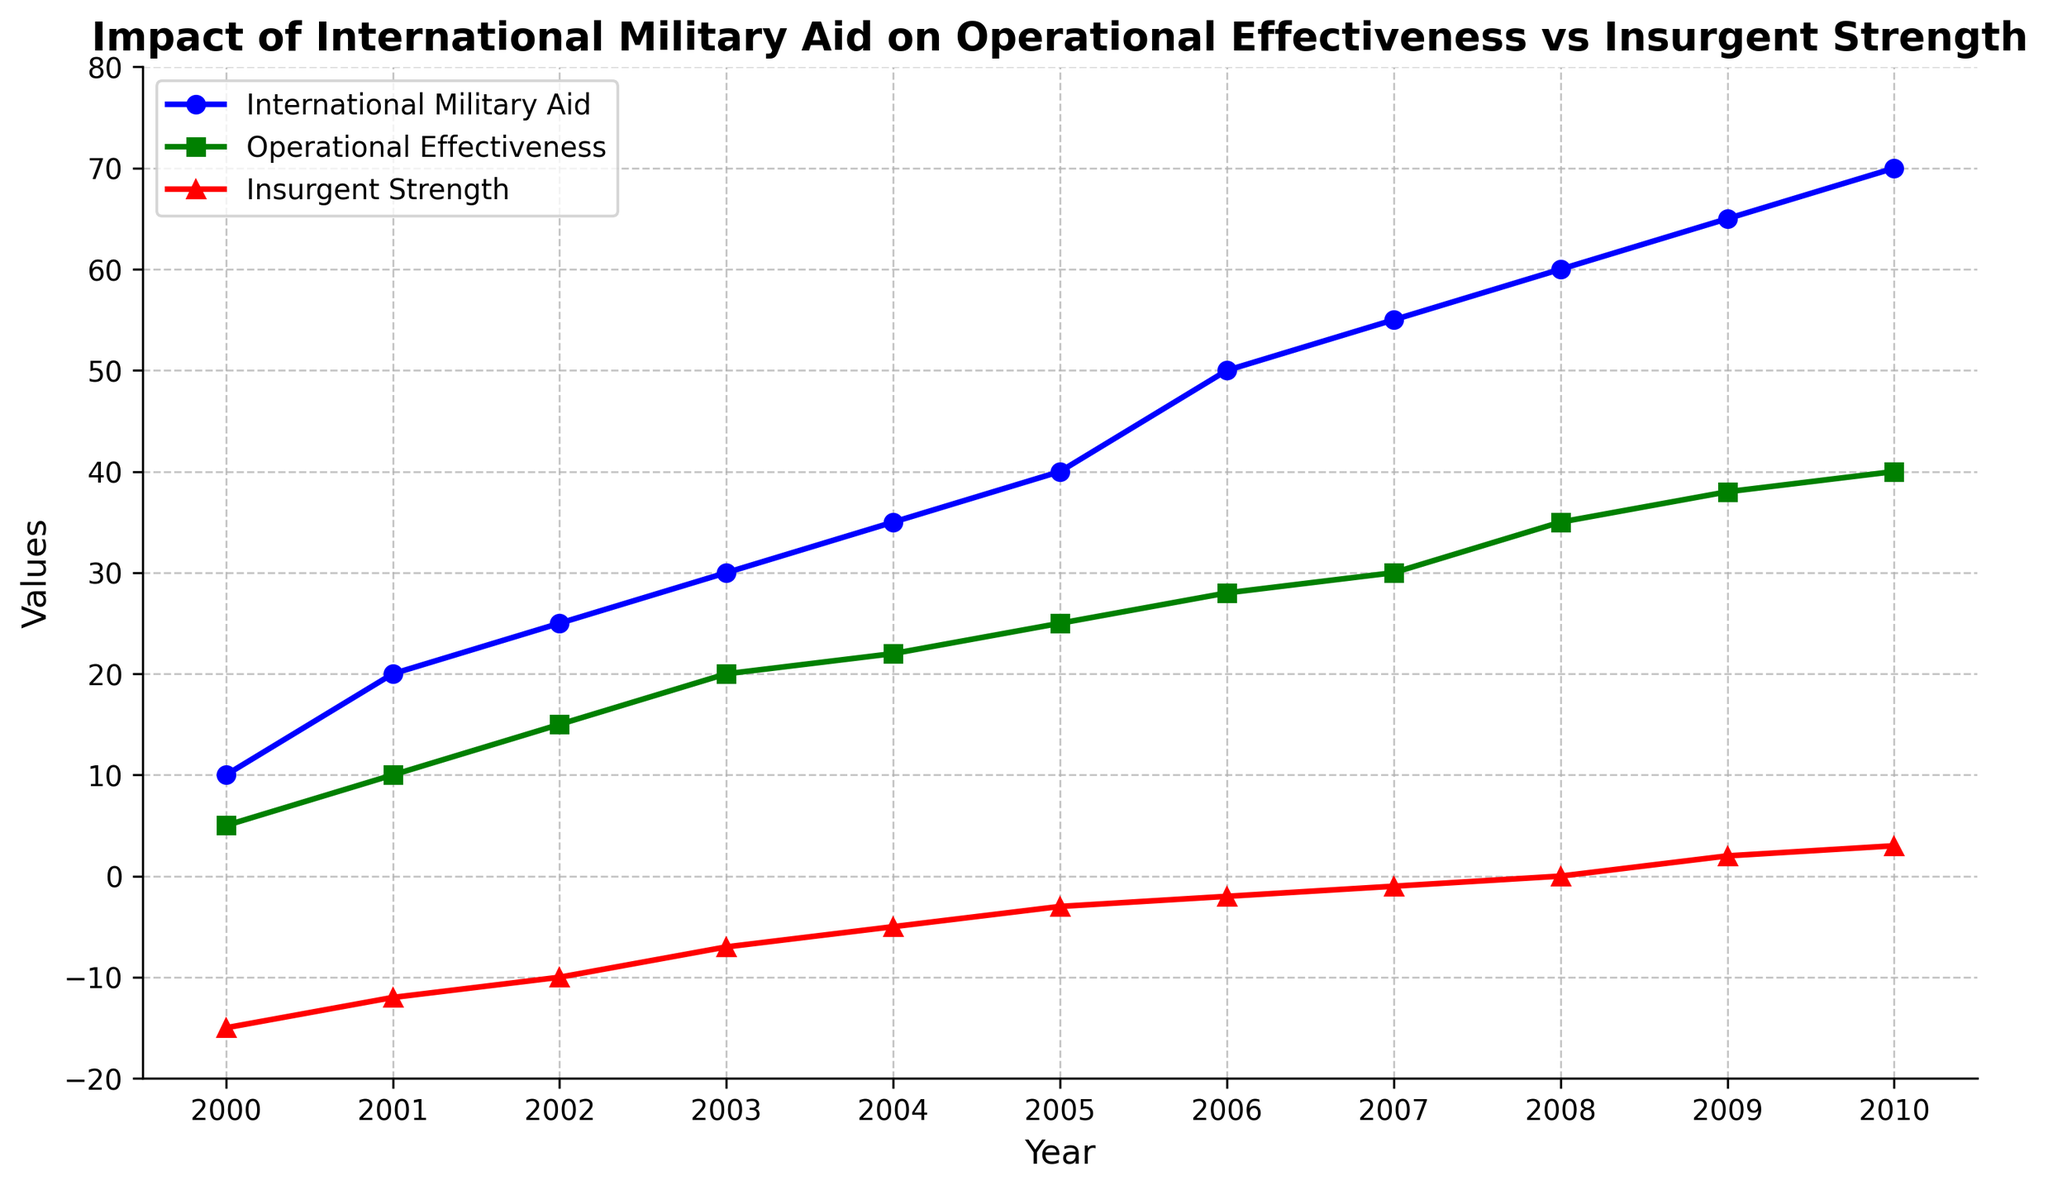What year did Operational Effectiveness first surpass Insurgent Strength? Looking at the plot, Operational Effectiveness surpassed Insurgent Strength in 2005 when the green line (Operational Effectiveness) rose above the red line (Insurgent Strength).
Answer: 2005 In which year did International Military Aid reach 60? Observing the blue line which represents International Military Aid, we see it hits 60 in the year 2008.
Answer: 2008 By how much did Insurgent Strength decrease from 2000 to 2004? Insurgent Strength in 2000 is -15, and in 2004 it is -5. The difference is found by subtracting the 2004 value from the 2000 value: -15 - (-5) = -10.
Answer: 10 Which had the steepest increase from one year to the next: International Military Aid between 2007 and 2008, or Operational Effectiveness between 2008 and 2009? The increase in International Military Aid from 2007 to 2008 is 60 - 55 = 5. For Operational Effectiveness from 2008 to 2009, it's 38 - 35 = 3. Therefore, International Military Aid had the steeper increase.
Answer: International Military Aid In which year did Operational Effectiveness have the same value as Insurgent Strength reached zero? Insurgent Strength reached zero in 2008, and in the same year, Operational Effectiveness was 35.
Answer: 2008 What was the ratio of International Military Aid to Insurgent Strength in 2006? In 2006, International Military Aid was 50, and Insurgent Strength was -2. The ratio is calculated as 50 / (-2) = -25.
Answer: -25 Which line is the highest in the year 2010? In 2010, based on the visual heights of the lines, International Military Aid (blue line) is the highest.
Answer: International Military Aid How much did Operational Effectiveness increase from 2000 to 2010? Operational Effectiveness in 2000 is 5 and in 2010 is 40. The increase is calculated by 40 - 5 = 35.
Answer: 35 In which year did International Military Aid and Operational Effectiveness have the same trend change (both increased)? Observing the lines, both International Military Aid (blue) and Operational Effectiveness (green) increased together from year to year. Such consistent trend is observed each year; for example in 2003.
Answer: Every year from 2000 to 2010 